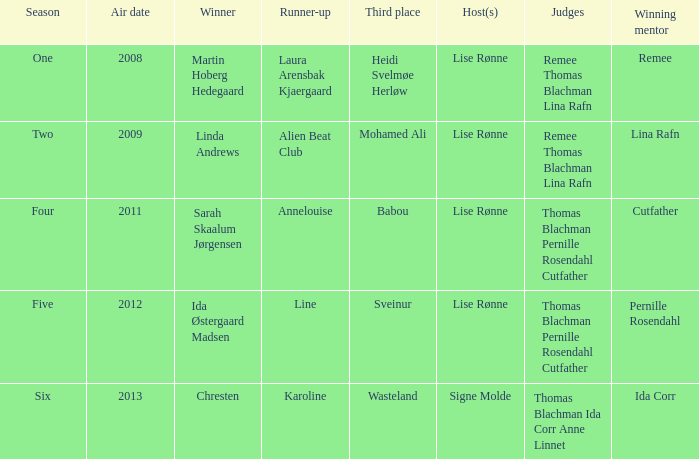During which season did ida corr achieve victory? Six. 